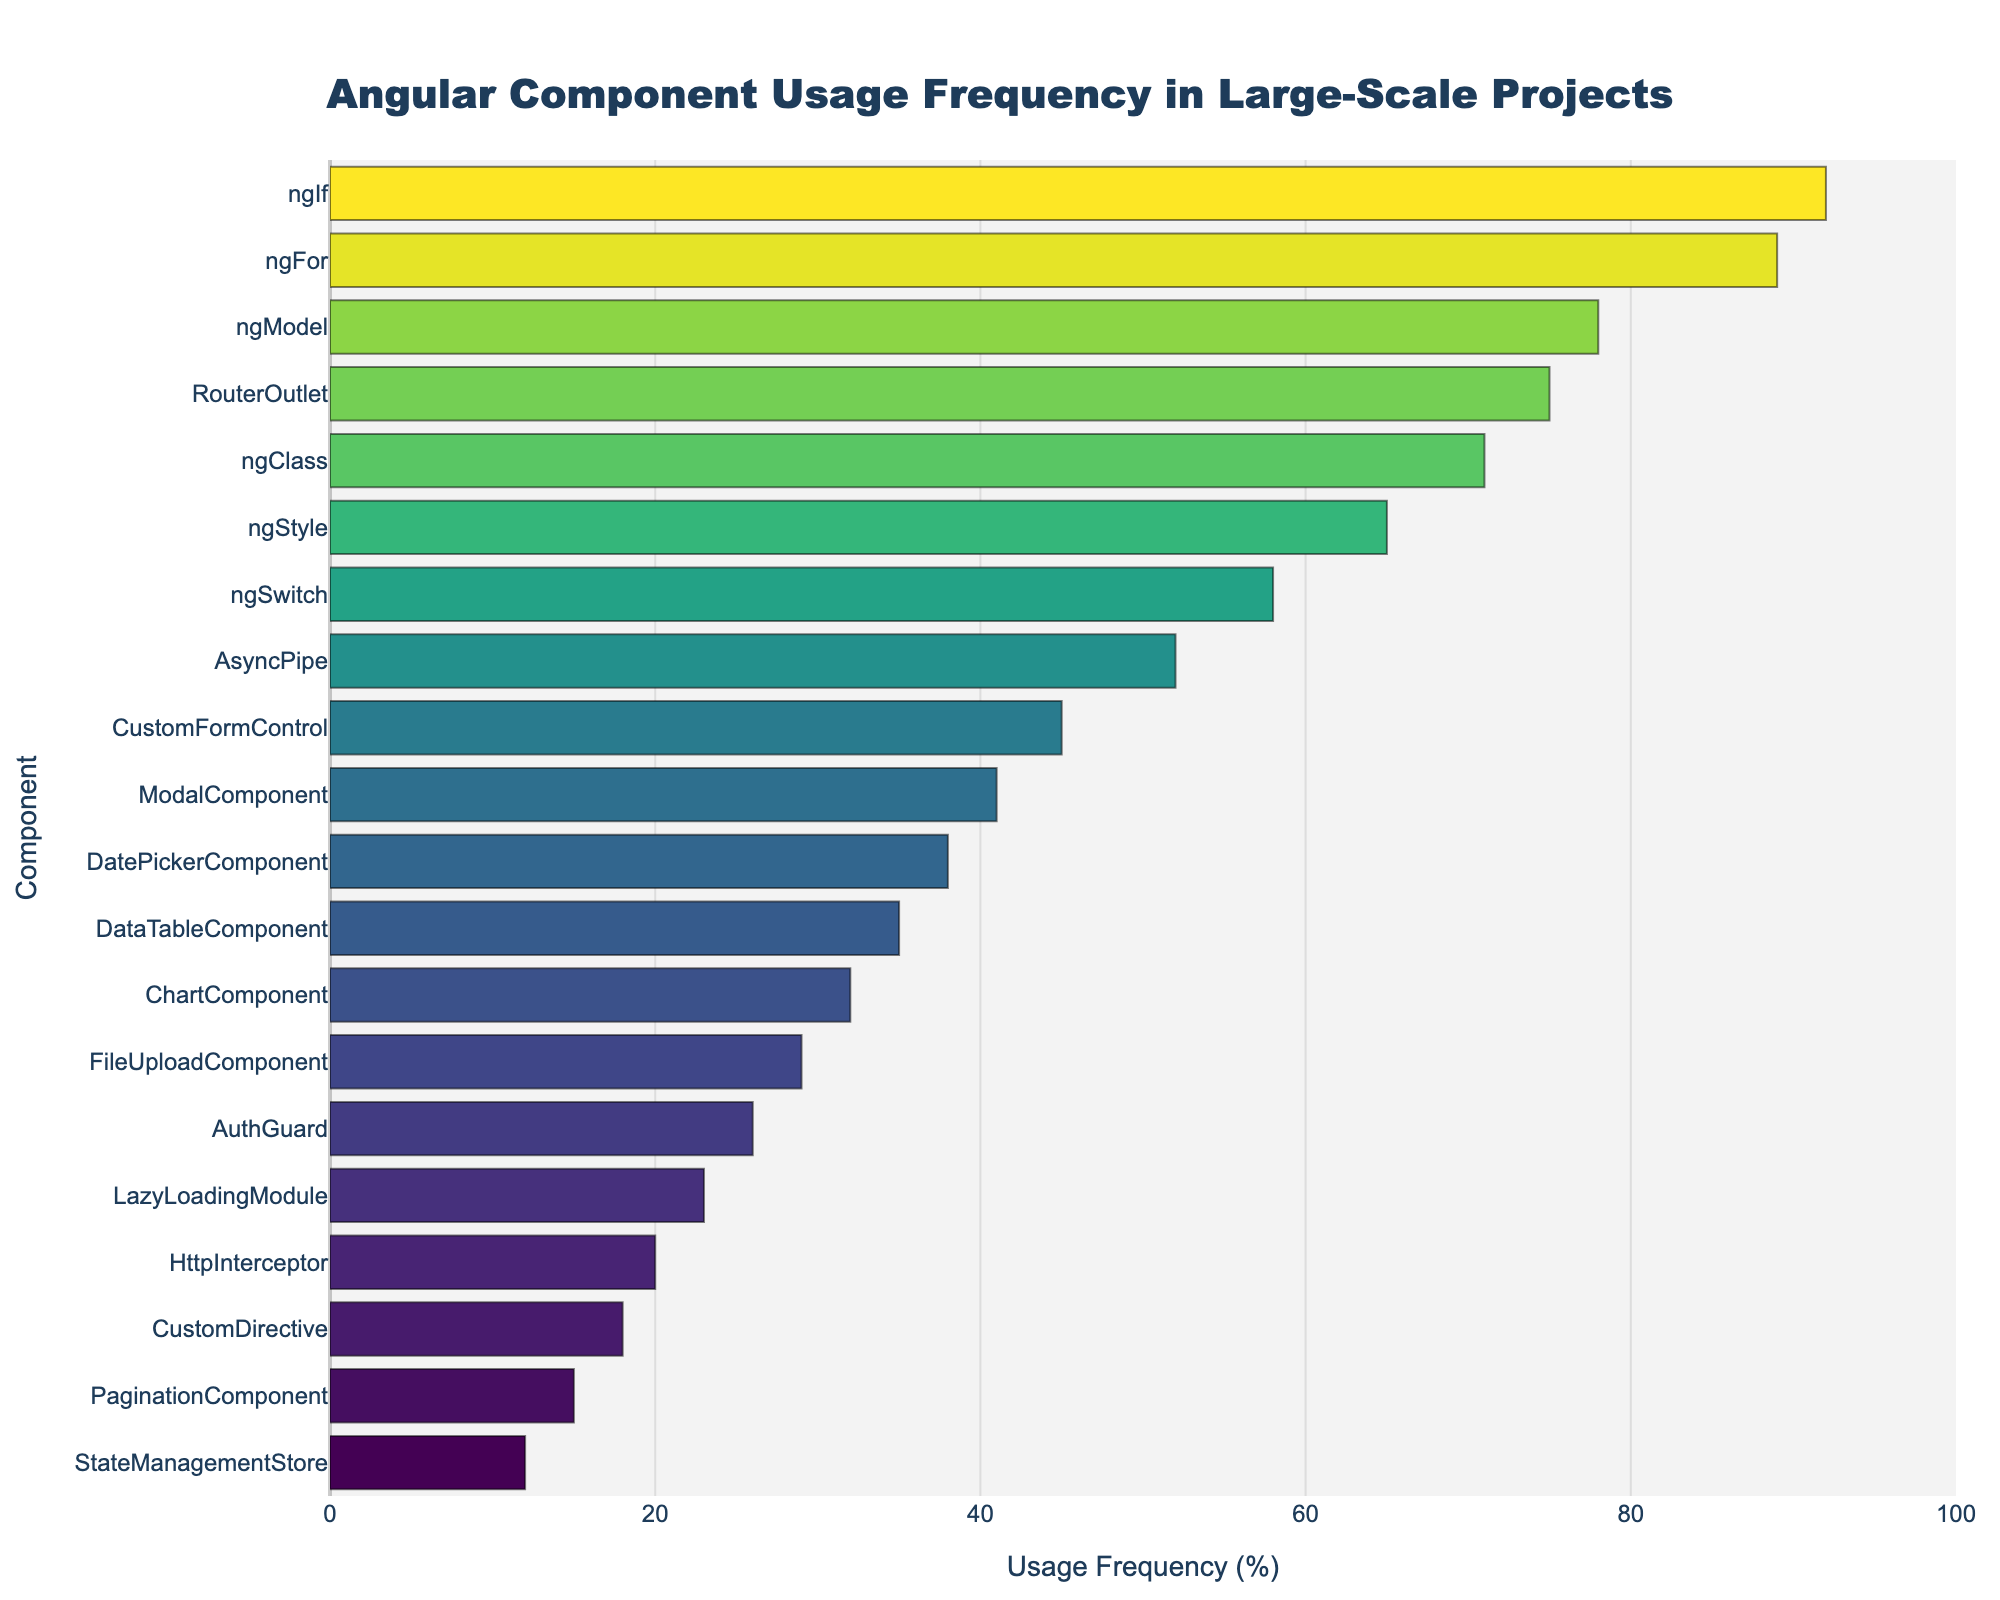what is the usage difference between 'ngIf' and 'ngFor'? To find the usage difference between 'ngIf' and 'ngFor', subtract the usage frequency of 'ngFor' (89%) from 'ngIf' (92%). So, 92% - 89% = 3%.
Answer: 3% which component has the lowest usage frequency? The lowest usage frequency can be identified by looking at the bottommost bar in the chart. 'StateManagementStore' has the lowest frequency at 12%.
Answer: StateManagementStore how many components have a usage frequency above 50%? Count the number of components whose usage frequency bar extends beyond the 50% mark. These are 'ngIf', 'ngFor', 'ngModel', 'RouterOutlet', 'ngClass', 'ngStyle', 'ngSwitch', and 'AsyncPipe', totaling 8 components.
Answer: 8 is 'ngModel' used more frequently than 'RouterOutlet'? By comparing the lengths of the bars for 'ngModel' (78%) and 'RouterOutlet' (75%), 'ngModel' is used more frequently.
Answer: Yes what is the combined usage frequency of 'CustomFormControl' and 'ModalComponent'? Add the usage frequencies of 'CustomFormControl' (45%) and 'ModalComponent' (41%). So, 45% + 41% = 86%.
Answer: 86% what visual color pattern do you notice in the bars? The bars use a colorscale ranging from lighter shades for lower frequencies to darker shades for higher frequencies, creating a gradient effect across the chart.
Answer: gradient which component ranks in the middle in terms of usage frequency? Arrange the components by usage frequency and identify the middle component. With 20 components, the middle one is the 10th when sorted from highest to lowest, which is 'CustomFormControl' with 45%.
Answer: CustomFormControl is 'AuthGuard' more or less frequently used than 'DatePickerComponent'? By comparing the heights of their bars, 'AuthGuard' (26%) is less frequently used than 'DatePickerComponent' (38%).
Answer: Less which color correlates with higher usage frequency of components? Identify the color used on bars with higher values. Darker shades of the colorscale indicate higher usage frequencies.
Answer: Darker shades what is the mean usage frequency of 'DataTableComponent', 'ChartComponent', and 'FileUploadComponent'? Calculate the mean of their usage frequencies: (35 + 32 + 29) / 3 = 32%.
Answer: 32% 